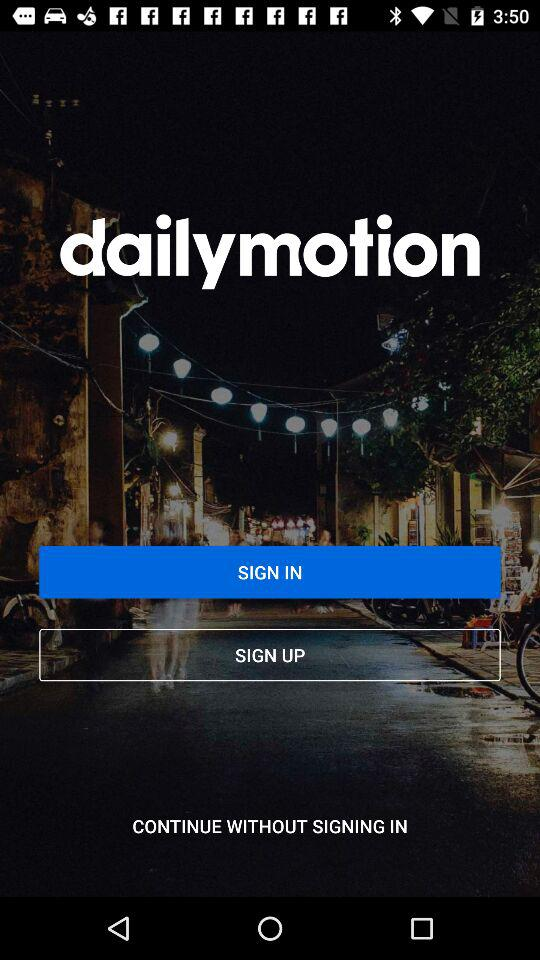What is the name of the application? The name of the application is "dailymotion". 